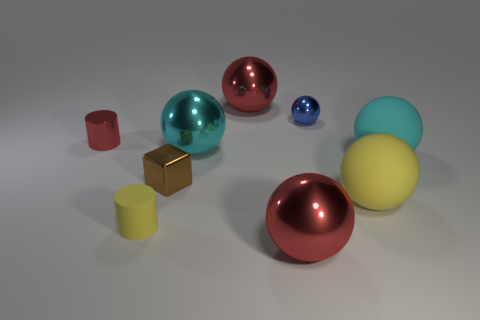Subtract all blue balls. How many balls are left? 5 Subtract all cyan metallic balls. How many balls are left? 5 Subtract all yellow spheres. Subtract all yellow cubes. How many spheres are left? 5 Add 1 gray rubber cylinders. How many objects exist? 10 Subtract all cubes. How many objects are left? 8 Subtract all red metallic cylinders. Subtract all tiny brown things. How many objects are left? 7 Add 8 blue shiny things. How many blue shiny things are left? 9 Add 2 big yellow rubber blocks. How many big yellow rubber blocks exist? 2 Subtract 0 green spheres. How many objects are left? 9 